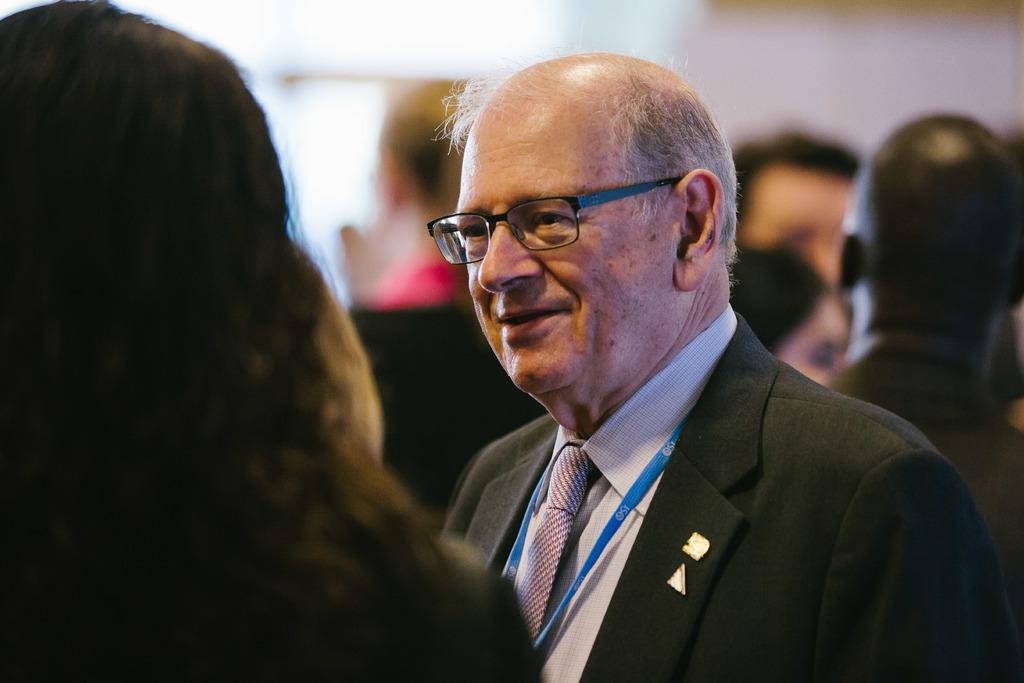Describe this image in one or two sentences. In the foreground of this image, on the left, there is a woman. In front of her, there is a man wearing suit. In the background, there are persons and remaining objects are blurred. 